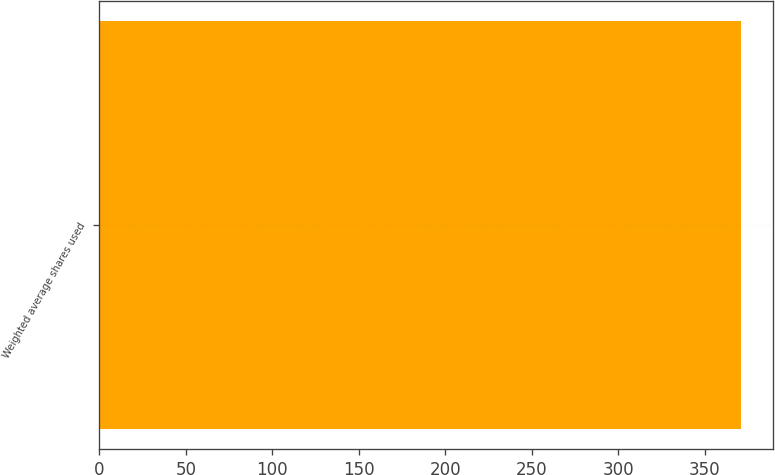<chart> <loc_0><loc_0><loc_500><loc_500><bar_chart><fcel>Weighted average shares used<nl><fcel>371<nl></chart> 